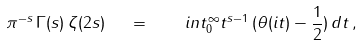<formula> <loc_0><loc_0><loc_500><loc_500>\pi ^ { - s } \, \Gamma ( s ) \, \zeta ( 2 s ) \ \ = \ \ \ i n t _ { 0 } ^ { \infty } t ^ { s - 1 } \, ( \theta ( i t ) - \frac { 1 } { 2 } ) \, d t \, ,</formula> 